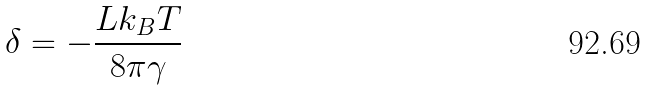Convert formula to latex. <formula><loc_0><loc_0><loc_500><loc_500>\delta = - \frac { L k _ { B } T } { 8 \pi \gamma }</formula> 